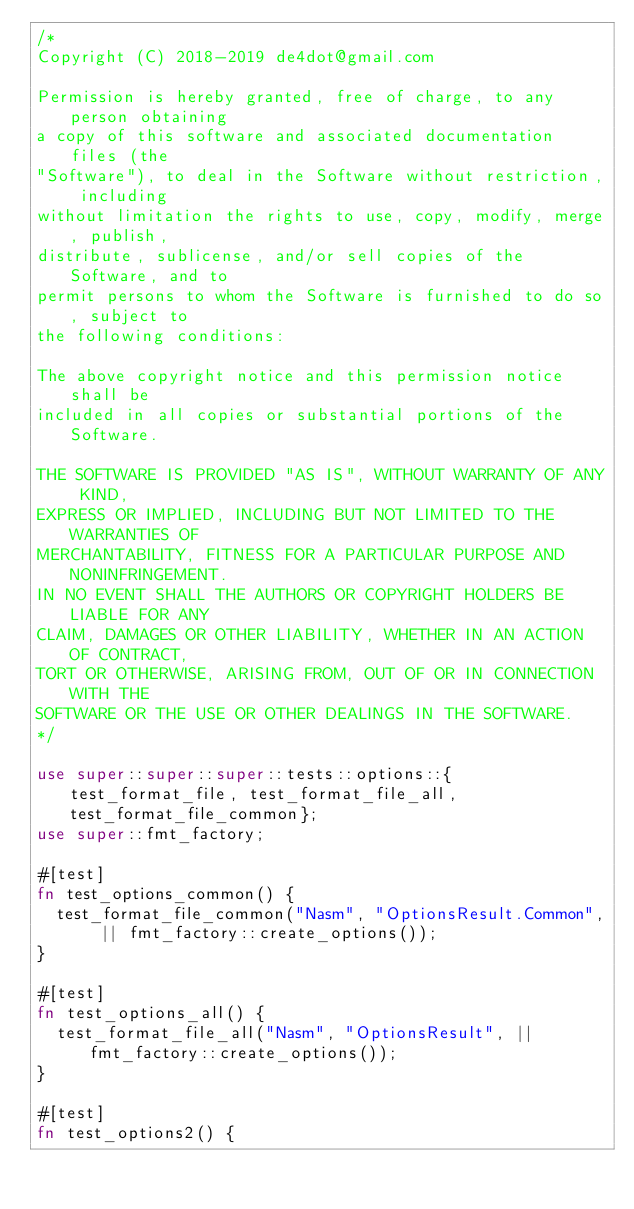Convert code to text. <code><loc_0><loc_0><loc_500><loc_500><_Rust_>/*
Copyright (C) 2018-2019 de4dot@gmail.com

Permission is hereby granted, free of charge, to any person obtaining
a copy of this software and associated documentation files (the
"Software"), to deal in the Software without restriction, including
without limitation the rights to use, copy, modify, merge, publish,
distribute, sublicense, and/or sell copies of the Software, and to
permit persons to whom the Software is furnished to do so, subject to
the following conditions:

The above copyright notice and this permission notice shall be
included in all copies or substantial portions of the Software.

THE SOFTWARE IS PROVIDED "AS IS", WITHOUT WARRANTY OF ANY KIND,
EXPRESS OR IMPLIED, INCLUDING BUT NOT LIMITED TO THE WARRANTIES OF
MERCHANTABILITY, FITNESS FOR A PARTICULAR PURPOSE AND NONINFRINGEMENT.
IN NO EVENT SHALL THE AUTHORS OR COPYRIGHT HOLDERS BE LIABLE FOR ANY
CLAIM, DAMAGES OR OTHER LIABILITY, WHETHER IN AN ACTION OF CONTRACT,
TORT OR OTHERWISE, ARISING FROM, OUT OF OR IN CONNECTION WITH THE
SOFTWARE OR THE USE OR OTHER DEALINGS IN THE SOFTWARE.
*/

use super::super::super::tests::options::{test_format_file, test_format_file_all, test_format_file_common};
use super::fmt_factory;

#[test]
fn test_options_common() {
	test_format_file_common("Nasm", "OptionsResult.Common", || fmt_factory::create_options());
}

#[test]
fn test_options_all() {
	test_format_file_all("Nasm", "OptionsResult", || fmt_factory::create_options());
}

#[test]
fn test_options2() {</code> 